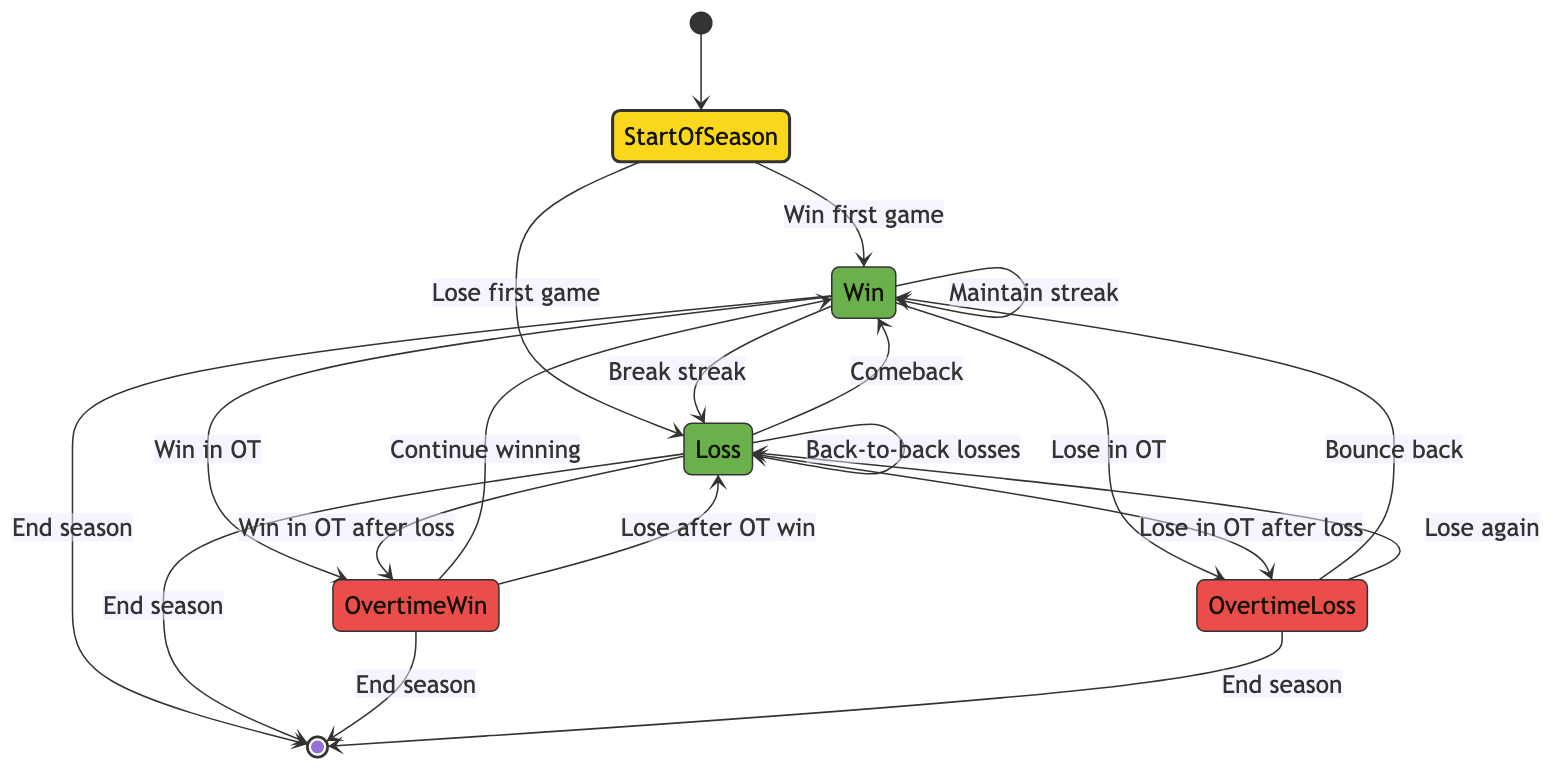What state follows "Start of Season" if the Idaho Vandals win their first game? According to the diagram, winning the first game moves the team from "Start of Season" to "Win". This is a direct transition indicated by the arrow labeled "Win first game".
Answer: Win How many states are represented in the diagram? Counting all distinct states listed in the diagram yields six: Start of Season, Win, Loss, Overtime Win, Overtime Loss, and End of Season.
Answer: Six What is the outcome if the Vandals lose their first game? If the Vandals lose their first game, the diagram indicates they transition to the "Loss" state. This is confirmed by the connected arrow from "Start of Season" to "Loss" labeled "Lose first game".
Answer: Loss What can happen after the Vandals achieve a win? After winning, the Vandals can either maintain their winning streak, lose their next game, win in overtime, or lose in overtime. These potential transitions are all indicated by arrows leading from the "Win" state to the respective outcomes.
Answer: Maintain streak, lose, Overtime Win, Overtime Loss What happens if the Vandals experience back-to-back losses? The diagram shows that if the Vandals lose a game and then lose the next one, they remain in the "Loss" state, indicated by the transition labeled "Back-to-back losses".
Answer: Loss After an overtime win, what could be the next outcomes? Following an overtime win, the Vandals can either continue winning or lose their next game as recorded in the transitions from "Overtime Win" to "Win" or "Loss".
Answer: Win, Loss How does the season end based on the results? The season can end after achieving a "Win", "Loss", "Overtime Win", or "Overtime Loss", as shown by arrows leading from each of these states to the "End of Season" state.
Answer: Win, Loss, Overtime Win, Overtime Loss What is the relationship between "Overtime Loss" and "Win"? If the Vandals suffer an overtime loss, they can bounce back with a win, as indicated by the arrow from "Overtime Loss" back to "Win" labeled "Bounce back".
Answer: Bounce back What state can be reached after experiencing a loss? After experiencing a loss, the Vandals may transition to either a win (if they recover) or continue losing, as indicated by the transitions from "Loss" leading to both "Win" and "Loss".
Answer: Win, Loss 